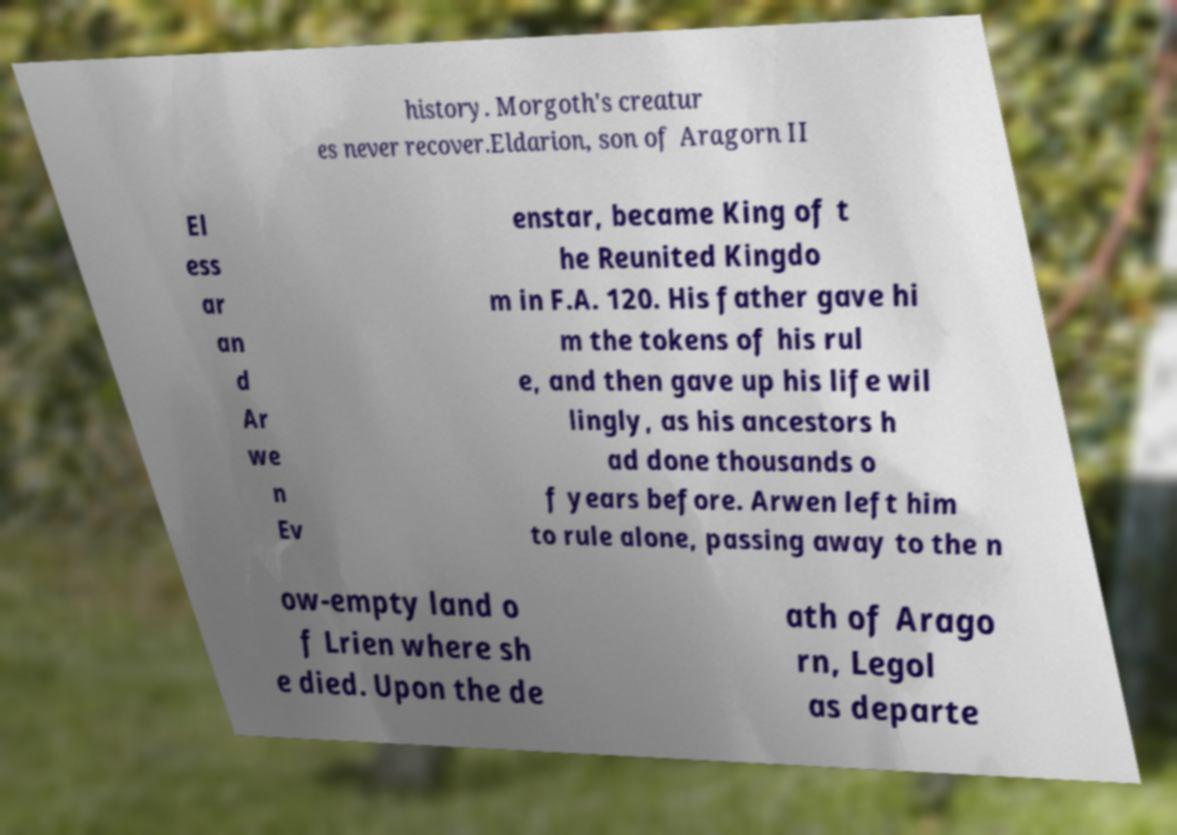There's text embedded in this image that I need extracted. Can you transcribe it verbatim? history. Morgoth's creatur es never recover.Eldarion, son of Aragorn II El ess ar an d Ar we n Ev enstar, became King of t he Reunited Kingdo m in F.A. 120. His father gave hi m the tokens of his rul e, and then gave up his life wil lingly, as his ancestors h ad done thousands o f years before. Arwen left him to rule alone, passing away to the n ow-empty land o f Lrien where sh e died. Upon the de ath of Arago rn, Legol as departe 